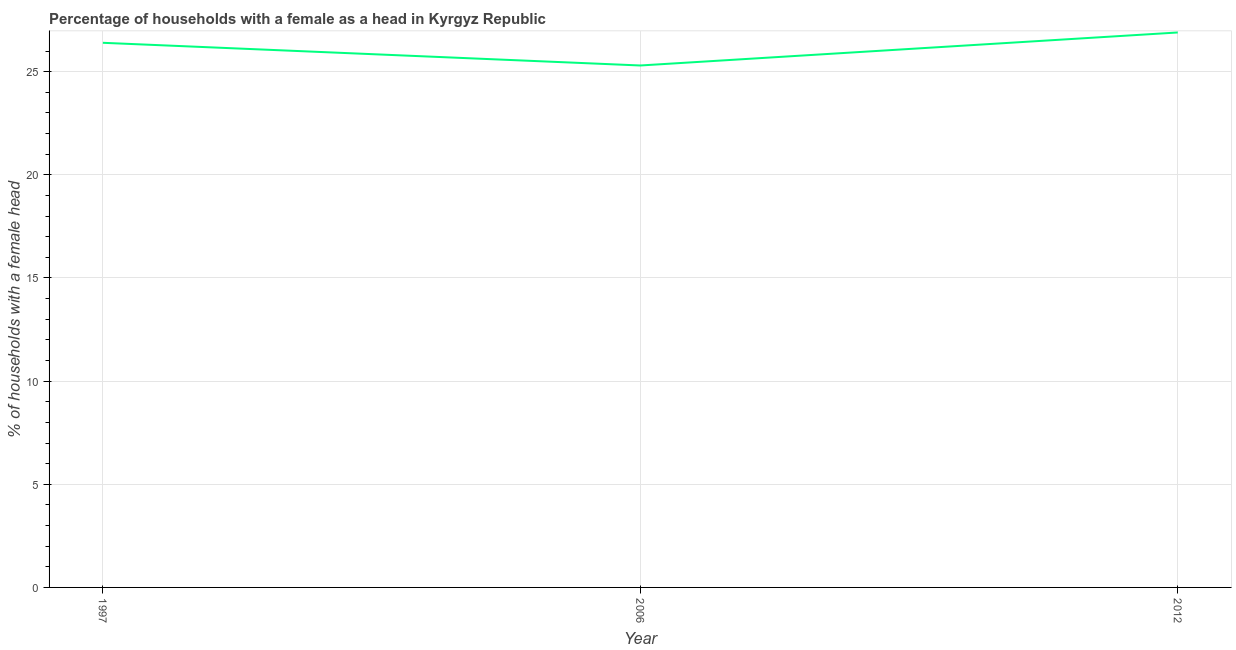What is the number of female supervised households in 2006?
Your response must be concise. 25.3. Across all years, what is the maximum number of female supervised households?
Ensure brevity in your answer.  26.9. Across all years, what is the minimum number of female supervised households?
Your answer should be compact. 25.3. In which year was the number of female supervised households minimum?
Make the answer very short. 2006. What is the sum of the number of female supervised households?
Provide a succinct answer. 78.6. What is the average number of female supervised households per year?
Offer a terse response. 26.2. What is the median number of female supervised households?
Provide a succinct answer. 26.4. Do a majority of the years between 2006 and 1997 (inclusive) have number of female supervised households greater than 12 %?
Provide a succinct answer. No. What is the ratio of the number of female supervised households in 1997 to that in 2006?
Your answer should be very brief. 1.04. Is the number of female supervised households in 1997 less than that in 2012?
Your answer should be very brief. Yes. Is the difference between the number of female supervised households in 1997 and 2006 greater than the difference between any two years?
Give a very brief answer. No. What is the difference between the highest and the second highest number of female supervised households?
Keep it short and to the point. 0.5. Is the sum of the number of female supervised households in 1997 and 2012 greater than the maximum number of female supervised households across all years?
Offer a terse response. Yes. What is the difference between the highest and the lowest number of female supervised households?
Ensure brevity in your answer.  1.6. In how many years, is the number of female supervised households greater than the average number of female supervised households taken over all years?
Provide a short and direct response. 2. How many lines are there?
Keep it short and to the point. 1. What is the difference between two consecutive major ticks on the Y-axis?
Give a very brief answer. 5. Are the values on the major ticks of Y-axis written in scientific E-notation?
Keep it short and to the point. No. What is the title of the graph?
Keep it short and to the point. Percentage of households with a female as a head in Kyrgyz Republic. What is the label or title of the X-axis?
Your answer should be very brief. Year. What is the label or title of the Y-axis?
Provide a succinct answer. % of households with a female head. What is the % of households with a female head of 1997?
Your answer should be very brief. 26.4. What is the % of households with a female head in 2006?
Provide a short and direct response. 25.3. What is the % of households with a female head of 2012?
Ensure brevity in your answer.  26.9. What is the difference between the % of households with a female head in 1997 and 2006?
Provide a succinct answer. 1.1. What is the ratio of the % of households with a female head in 1997 to that in 2006?
Make the answer very short. 1.04. What is the ratio of the % of households with a female head in 2006 to that in 2012?
Make the answer very short. 0.94. 